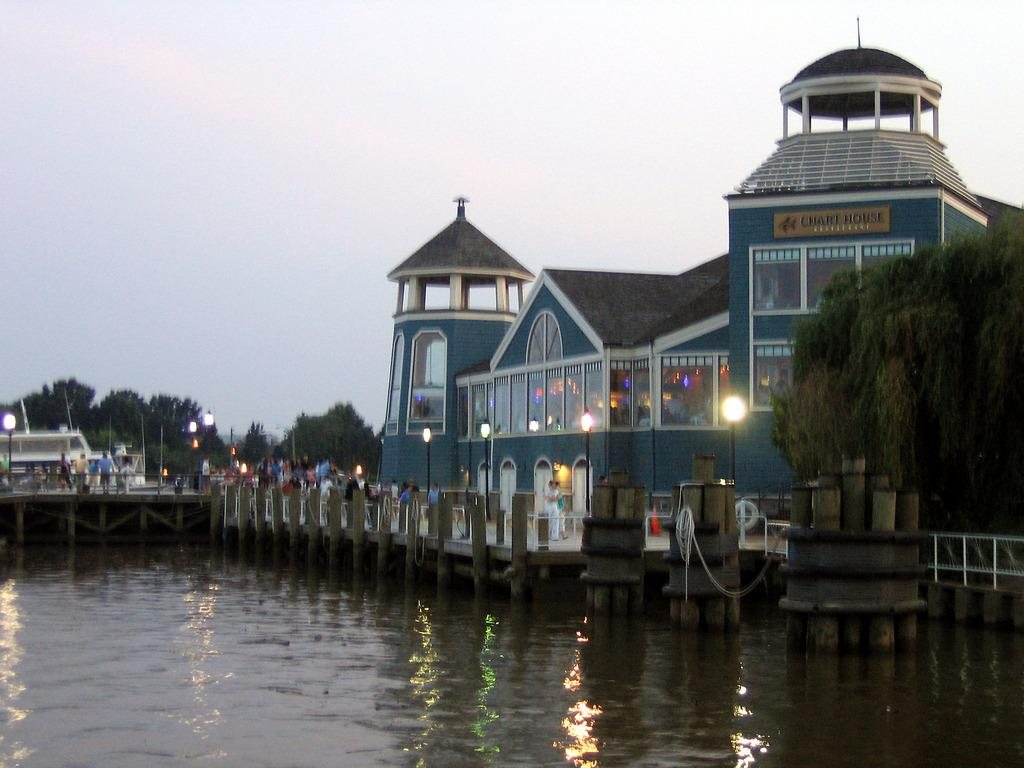<image>
Create a compact narrative representing the image presented. Many people stand on the pier outside of the Chart House. 